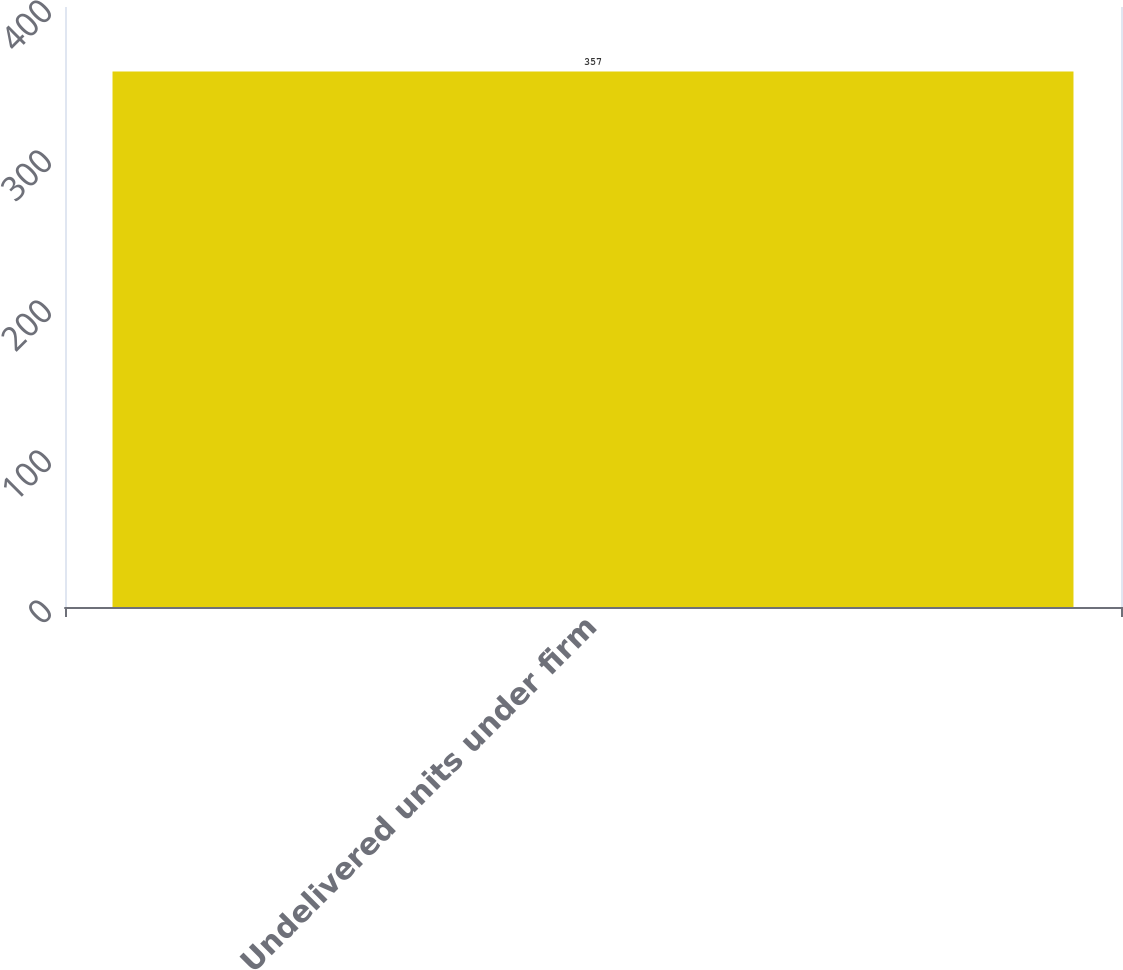Convert chart. <chart><loc_0><loc_0><loc_500><loc_500><bar_chart><fcel>Undelivered units under firm<nl><fcel>357<nl></chart> 